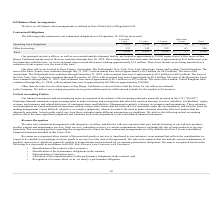According to Mitek Systems's financial document, Where are the principal executive offices, as well as research and development facility located? San Diego, California. The document states: "Other than the lease for our office space in San Diego, California, we do not believe that the leases for our offices are material..." Also, How much is the annual base rent for the office in Barcelona, Spain? approximately €0.1 million (or $0.1 million). The document states: "through May 31, 2023, with an annual base rent of approximately €0.1 million (or $0.1 million). The term of the London, United Kingdom lease continues..." Also, How much are the total overall contractual obligations ? According to the financial document, $8,948 (in thousands). The relevant text states: "Total $ 1,830 $ 4,095 $ 2,926 $ 97 $ 8,948..." Also, can you calculate: What is the proportion of total operating lease obligations that expire in 3 years over total operating lease obligations? To answer this question, I need to perform calculations using the financial data. The calculation is: (1,699+3,950)/8,392 , which equals 0.67. This is based on the information: "lease obligations $ 1,699 $ 3,950 $ 2,707 $ 36 $ 8,392 Operating lease obligations $ 1,699 $ 3,950 $ 2,707 $ 36 $ 8,392 Operating lease obligations $ 1,699 $ 3,950 $ 2,707 $ 36 $ 8,392..." The key data points involved are: 1,699, 3,950, 8,392. Also, can you calculate: What is the ratio of contractual obligations that expire in less than 1 year to the ones that expire in 3-5 years? Based on the calculation: 1,830/2,926 , the result is 0.63. This is based on the information: "Total $ 1,830 $ 4,095 $ 2,926 $ 97 $ 8,948 Total $ 1,830 $ 4,095 $ 2,926 $ 97 $ 8,948..." The key data points involved are: 1,830, 2,926. Also, can you calculate: What is the average contractual obligation based on the different term periods of the lease? To answer this question, I need to perform calculations using the financial data. The calculation is: (1,830+4,095+2,926+97)/5 , which equals 1789.6 (in thousands). This is based on the information: "Total $ 1,830 $ 4,095 $ 2,926 $ 97 $ 8,948 Total $ 1,830 $ 4,095 $ 2,926 $ 97 $ 8,948 Total $ 1,830 $ 4,095 $ 2,926 $ 97 $ 8,948 Total $ 1,830 $ 4,095 $ 2,926 $ 97 $ 8,948..." The key data points involved are: 1,830, 2,926, 4,095. 